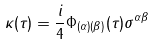Convert formula to latex. <formula><loc_0><loc_0><loc_500><loc_500>\kappa ( \tau ) = \frac { i } { 4 } \Phi _ { ( \alpha ) ( \beta ) } ( \tau ) \sigma ^ { \alpha \beta }</formula> 